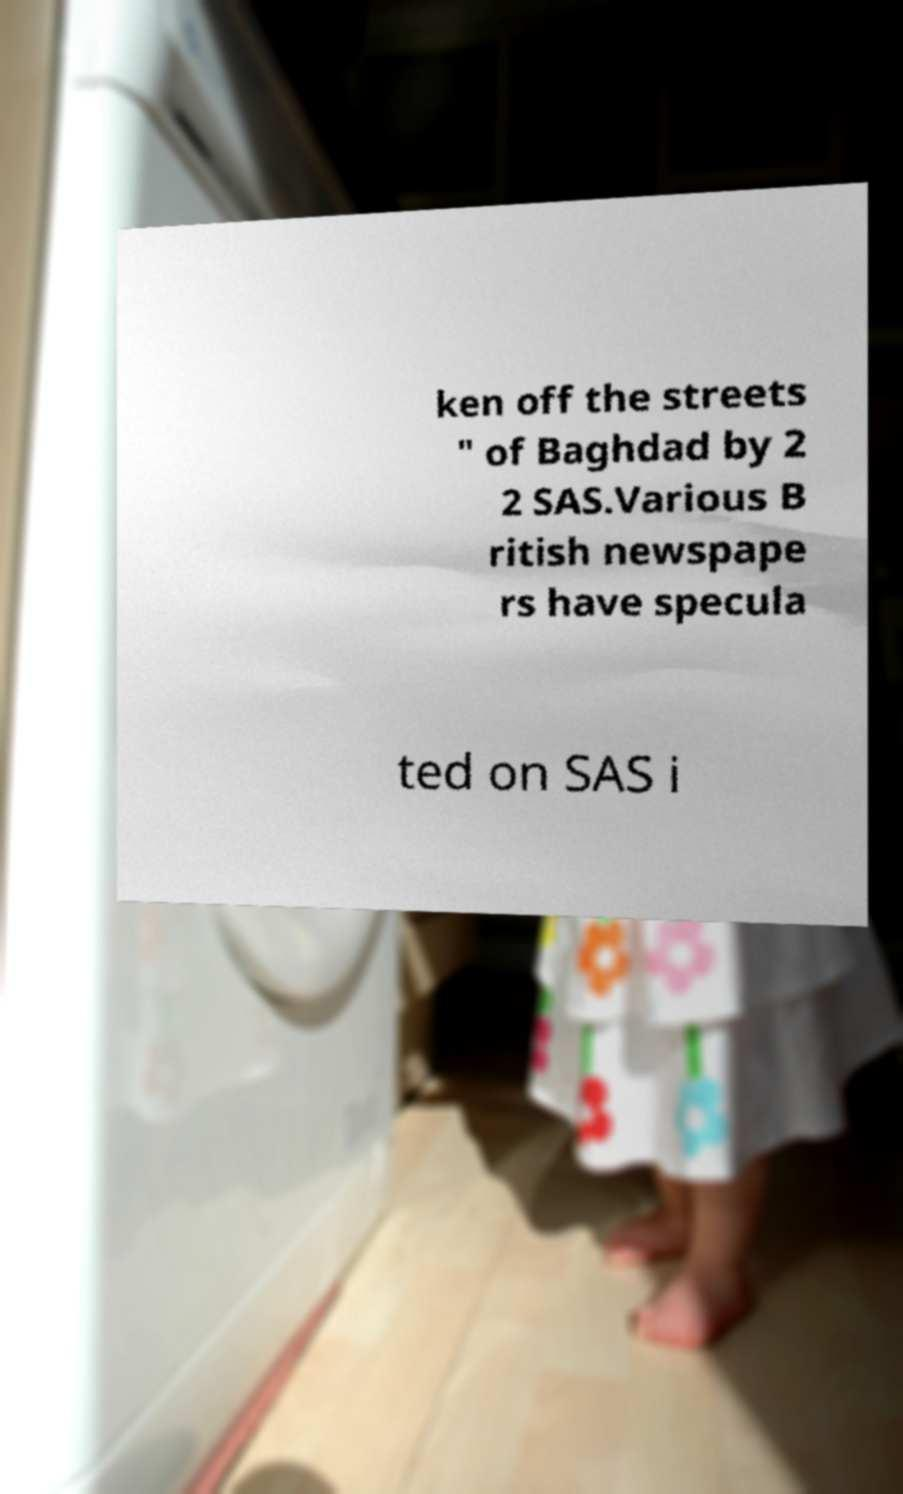Please read and relay the text visible in this image. What does it say? ken off the streets " of Baghdad by 2 2 SAS.Various B ritish newspape rs have specula ted on SAS i 